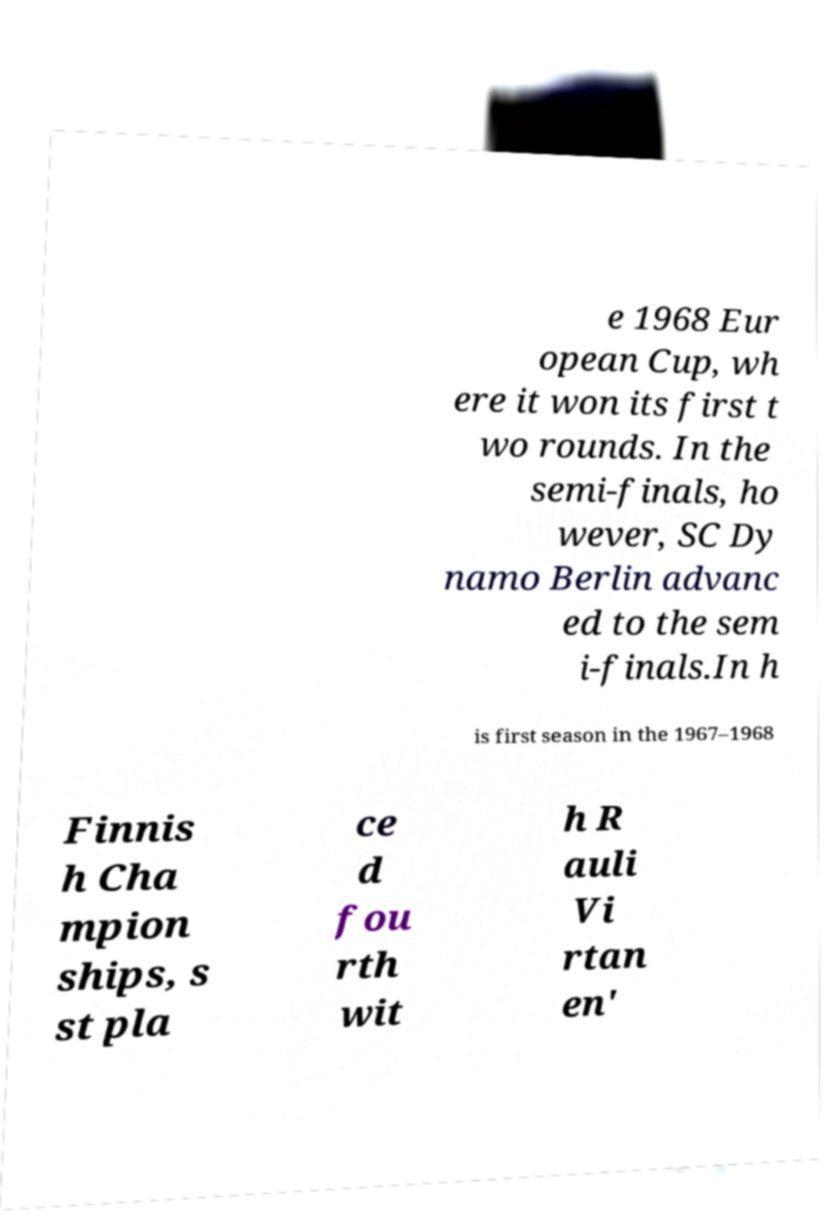Could you extract and type out the text from this image? e 1968 Eur opean Cup, wh ere it won its first t wo rounds. In the semi-finals, ho wever, SC Dy namo Berlin advanc ed to the sem i-finals.In h is first season in the 1967–1968 Finnis h Cha mpion ships, s st pla ce d fou rth wit h R auli Vi rtan en' 